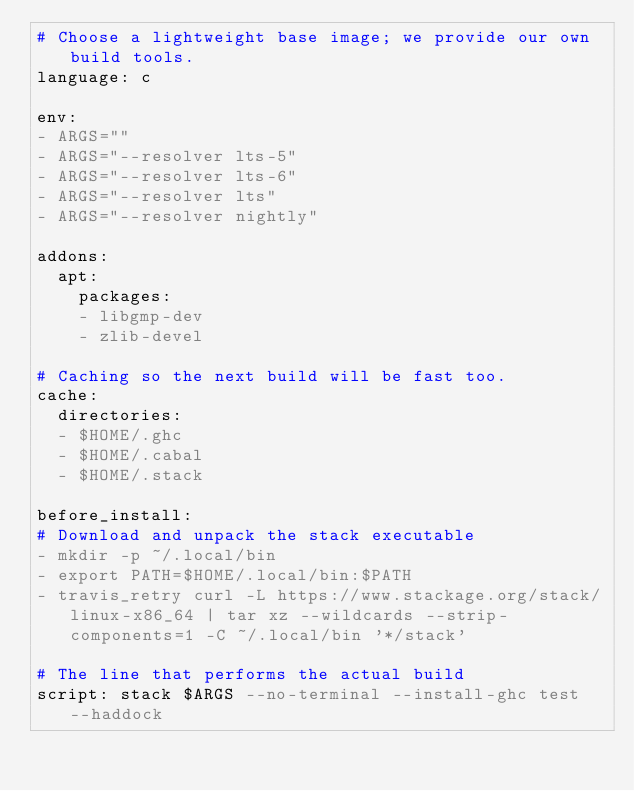<code> <loc_0><loc_0><loc_500><loc_500><_YAML_># Choose a lightweight base image; we provide our own build tools.
language: c

env:
- ARGS=""
- ARGS="--resolver lts-5"
- ARGS="--resolver lts-6"
- ARGS="--resolver lts"
- ARGS="--resolver nightly"

addons:
  apt:
    packages:
    - libgmp-dev
    - zlib-devel

# Caching so the next build will be fast too.
cache:
  directories:
  - $HOME/.ghc
  - $HOME/.cabal
  - $HOME/.stack

before_install:
# Download and unpack the stack executable
- mkdir -p ~/.local/bin
- export PATH=$HOME/.local/bin:$PATH
- travis_retry curl -L https://www.stackage.org/stack/linux-x86_64 | tar xz --wildcards --strip-components=1 -C ~/.local/bin '*/stack'

# The line that performs the actual build
script: stack $ARGS --no-terminal --install-ghc test --haddock
</code> 